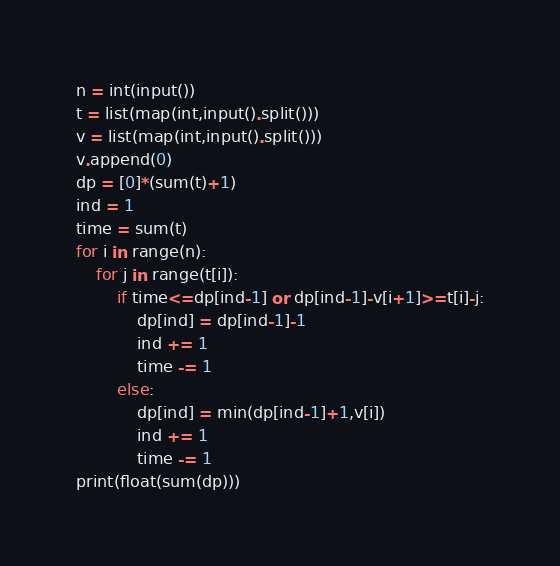Convert code to text. <code><loc_0><loc_0><loc_500><loc_500><_Python_>n = int(input())
t = list(map(int,input().split()))
v = list(map(int,input().split()))
v.append(0)
dp = [0]*(sum(t)+1)
ind = 1
time = sum(t)
for i in range(n):
    for j in range(t[i]):
        if time<=dp[ind-1] or dp[ind-1]-v[i+1]>=t[i]-j:
            dp[ind] = dp[ind-1]-1
            ind += 1
            time -= 1
        else:
            dp[ind] = min(dp[ind-1]+1,v[i])
            ind += 1
            time -= 1
print(float(sum(dp)))</code> 